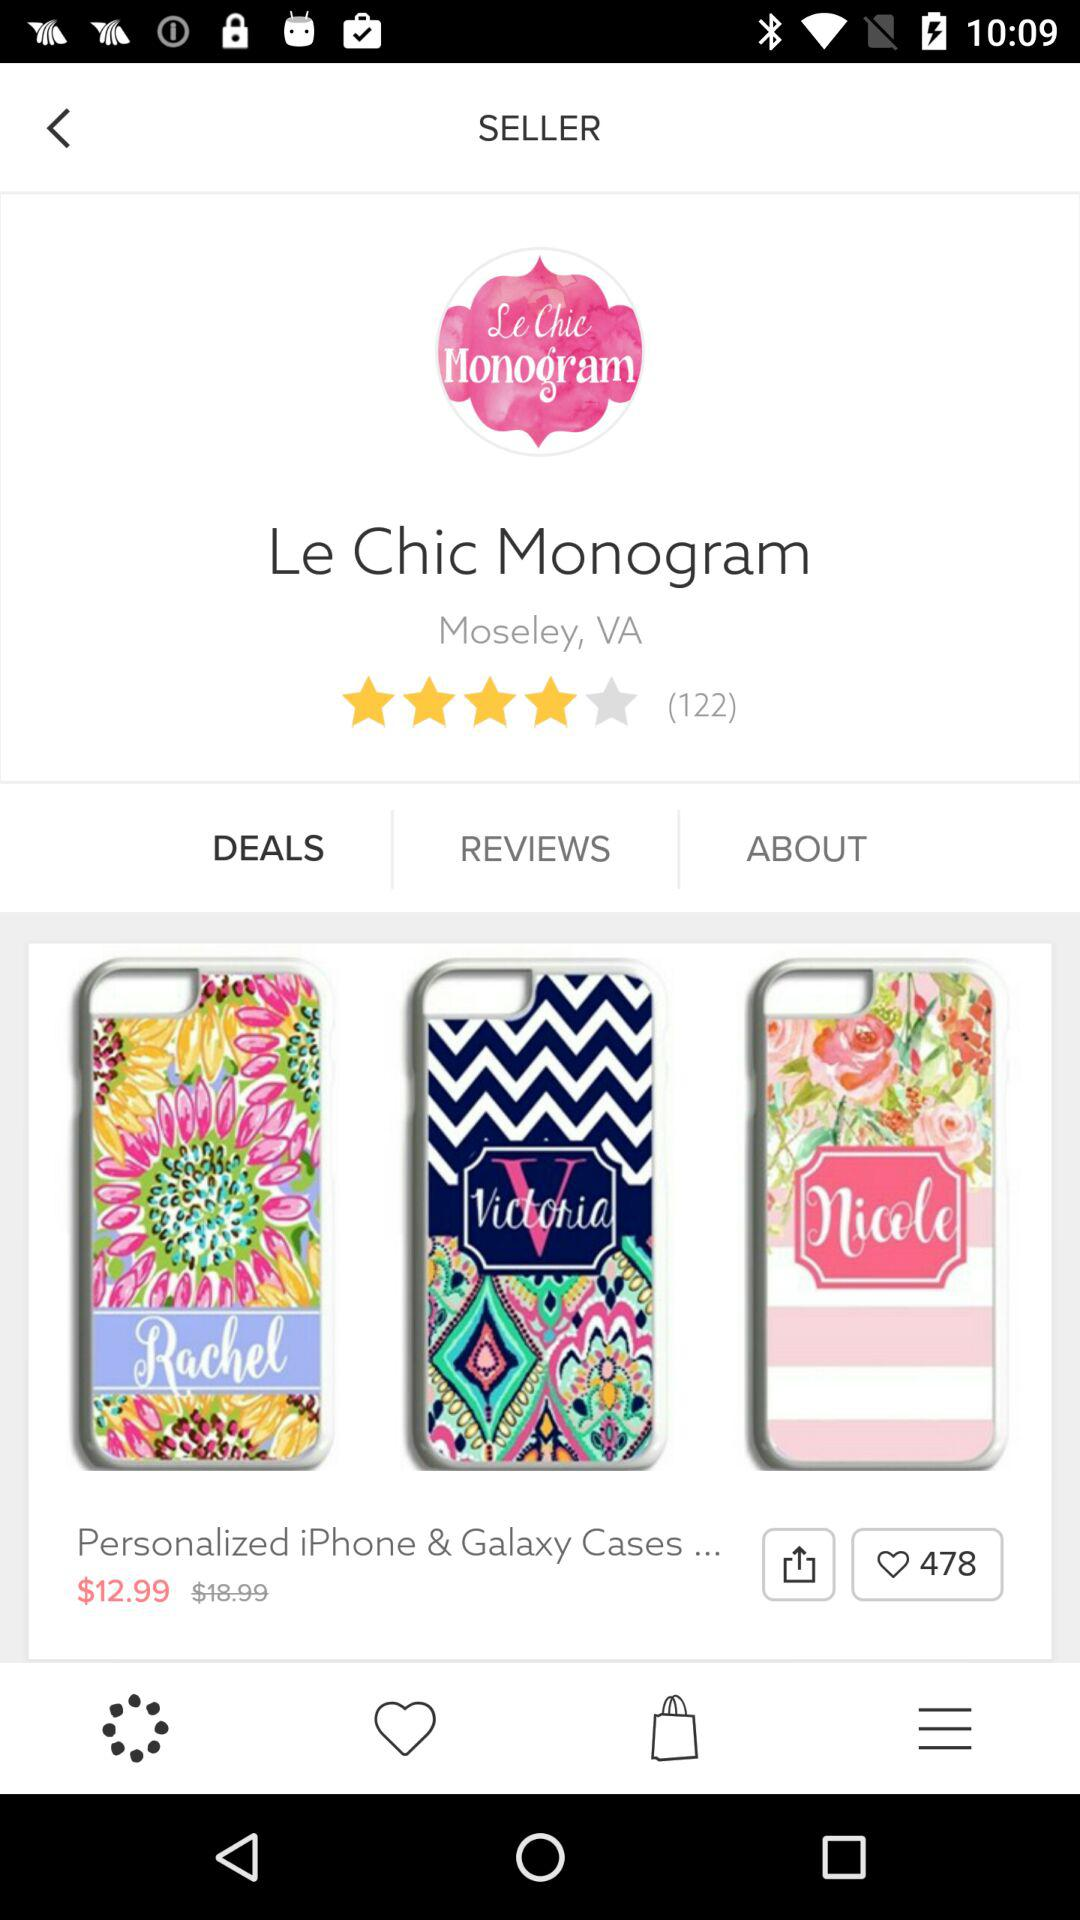What is the price of "Personalized iPhone & Galaxy Cases..."? The price is $12.99. 